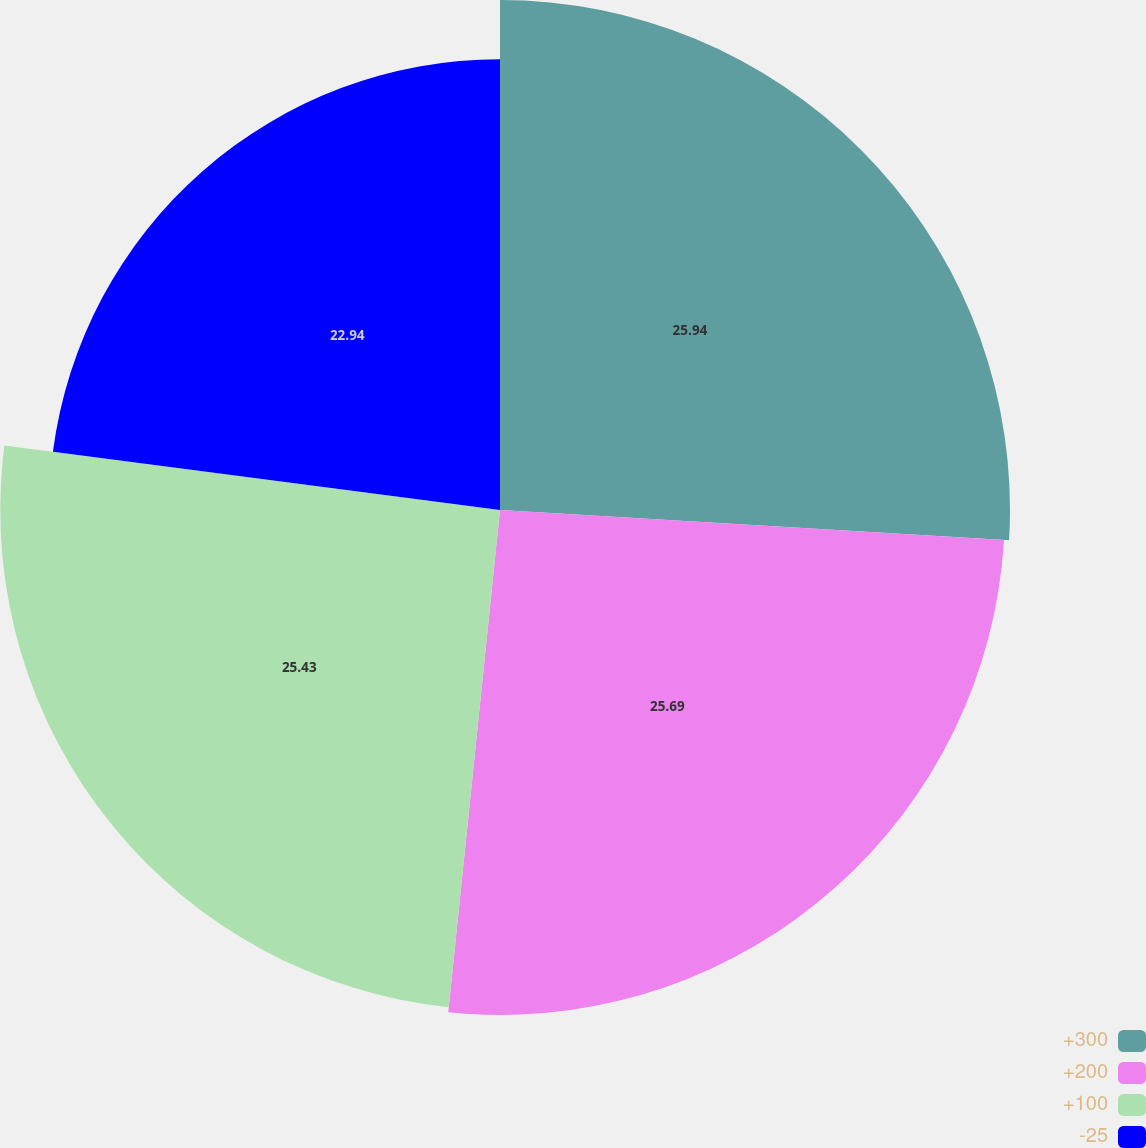Convert chart to OTSL. <chart><loc_0><loc_0><loc_500><loc_500><pie_chart><fcel>+300<fcel>+200<fcel>+100<fcel>-25<nl><fcel>25.95%<fcel>25.69%<fcel>25.43%<fcel>22.94%<nl></chart> 